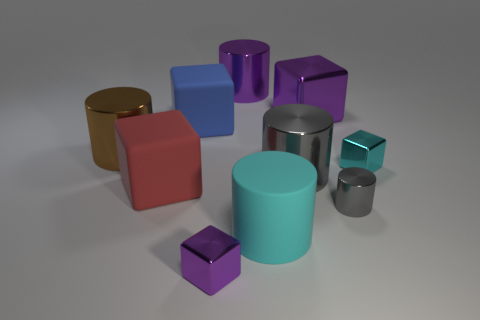Subtract all gray cylinders. How many were subtracted if there are1gray cylinders left? 1 Subtract all big rubber cylinders. How many cylinders are left? 4 Subtract 0 gray blocks. How many objects are left? 10 Subtract 4 cubes. How many cubes are left? 1 Subtract all purple cubes. Subtract all blue cylinders. How many cubes are left? 3 Subtract all gray blocks. How many brown cylinders are left? 1 Subtract all large shiny blocks. Subtract all purple shiny cylinders. How many objects are left? 8 Add 3 big cubes. How many big cubes are left? 6 Add 2 large red metal cubes. How many large red metal cubes exist? 2 Subtract all purple cylinders. How many cylinders are left? 4 